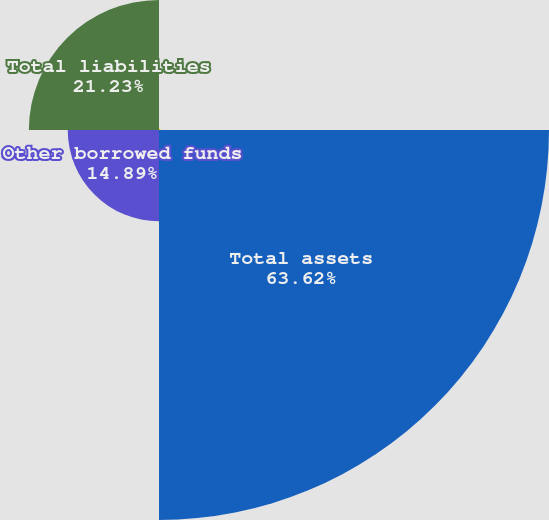Convert chart to OTSL. <chart><loc_0><loc_0><loc_500><loc_500><pie_chart><fcel>Other assets<fcel>Total assets<fcel>Other borrowed funds<fcel>Total liabilities<nl><fcel>0.26%<fcel>63.63%<fcel>14.89%<fcel>21.23%<nl></chart> 